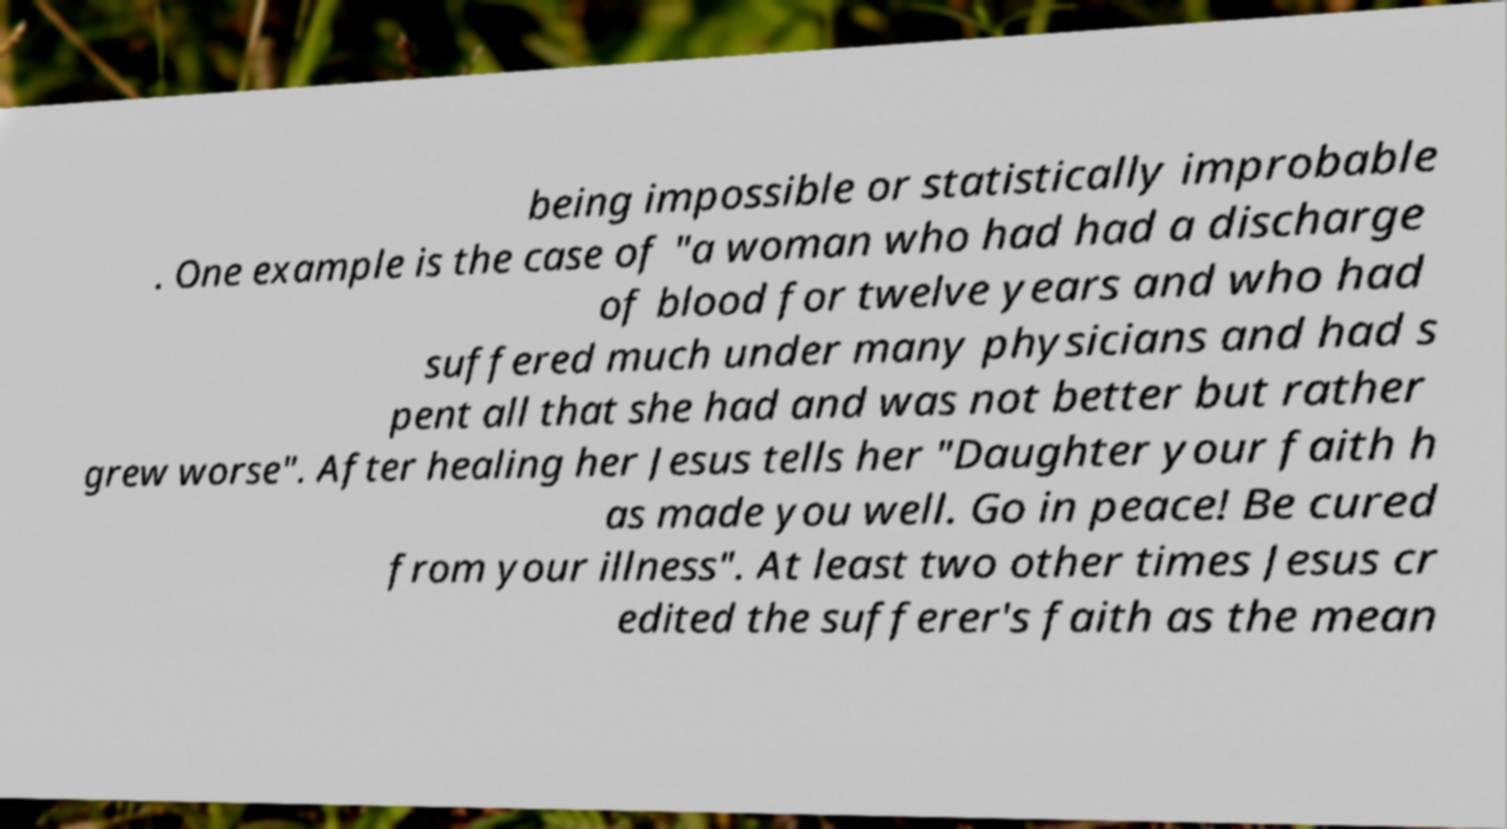Please identify and transcribe the text found in this image. being impossible or statistically improbable . One example is the case of "a woman who had had a discharge of blood for twelve years and who had suffered much under many physicians and had s pent all that she had and was not better but rather grew worse". After healing her Jesus tells her "Daughter your faith h as made you well. Go in peace! Be cured from your illness". At least two other times Jesus cr edited the sufferer's faith as the mean 